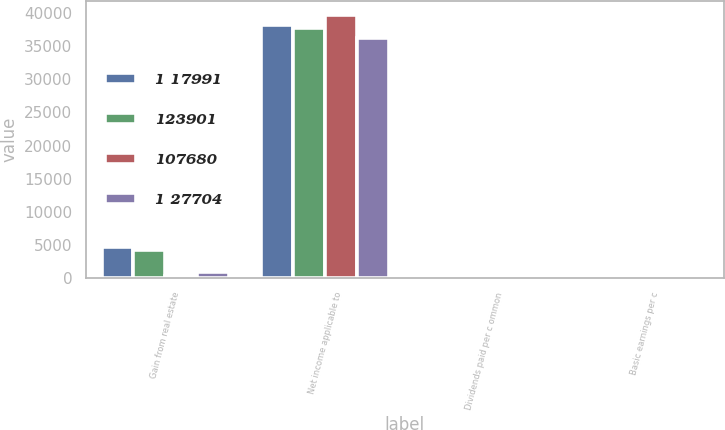<chart> <loc_0><loc_0><loc_500><loc_500><stacked_bar_chart><ecel><fcel>Gain from real estate<fcel>Net income applicable to<fcel>Dividends paid per c ommon<fcel>Basic earnings per c<nl><fcel>1 17991<fcel>4738<fcel>38175<fcel>0.42<fcel>0.29<nl><fcel>123901<fcel>4166<fcel>37764<fcel>0.42<fcel>0.28<nl><fcel>107680<fcel>273<fcel>39759<fcel>0.42<fcel>0.29<nl><fcel>1 27704<fcel>979<fcel>36229<fcel>0.42<fcel>0.27<nl></chart> 